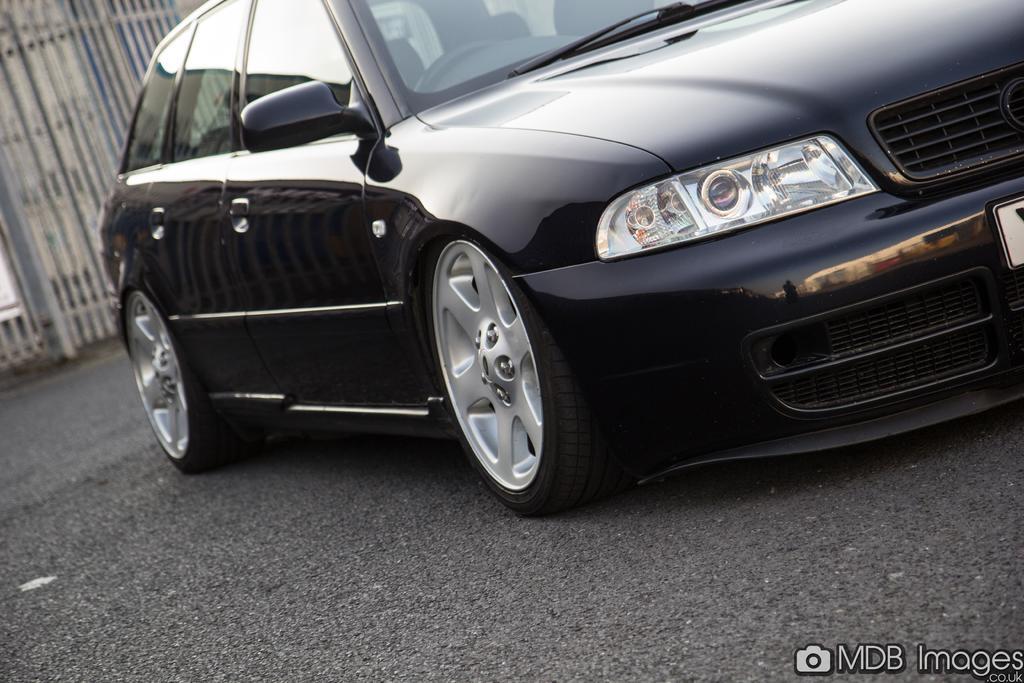How would you summarize this image in a sentence or two? In this image there is a black car on the road. In the background there is a fence. 